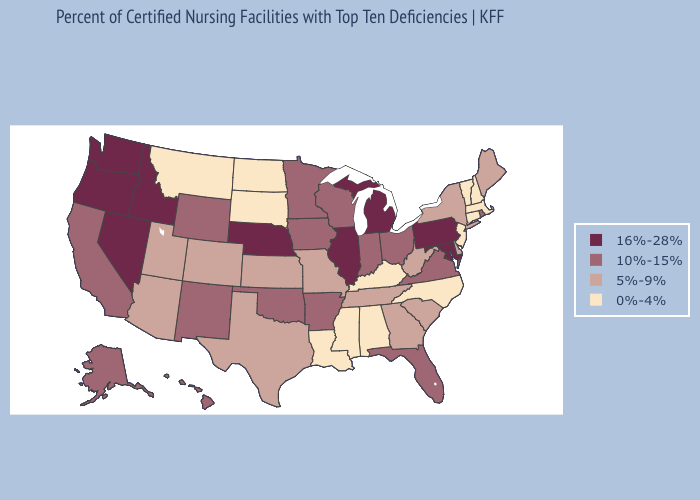Does the map have missing data?
Give a very brief answer. No. Does Washington have a lower value than Delaware?
Quick response, please. No. Does Ohio have the highest value in the MidWest?
Answer briefly. No. What is the lowest value in the South?
Be succinct. 0%-4%. What is the highest value in the Northeast ?
Quick response, please. 16%-28%. What is the value of New York?
Give a very brief answer. 5%-9%. What is the lowest value in states that border Maryland?
Answer briefly. 5%-9%. Does Kansas have a lower value than Hawaii?
Keep it brief. Yes. What is the highest value in the USA?
Write a very short answer. 16%-28%. Does Nevada have the highest value in the USA?
Be succinct. Yes. Does the first symbol in the legend represent the smallest category?
Short answer required. No. What is the highest value in states that border Georgia?
Give a very brief answer. 10%-15%. Does Washington have the same value as Nevada?
Quick response, please. Yes. Among the states that border Mississippi , which have the lowest value?
Answer briefly. Alabama, Louisiana. What is the lowest value in states that border Utah?
Give a very brief answer. 5%-9%. 